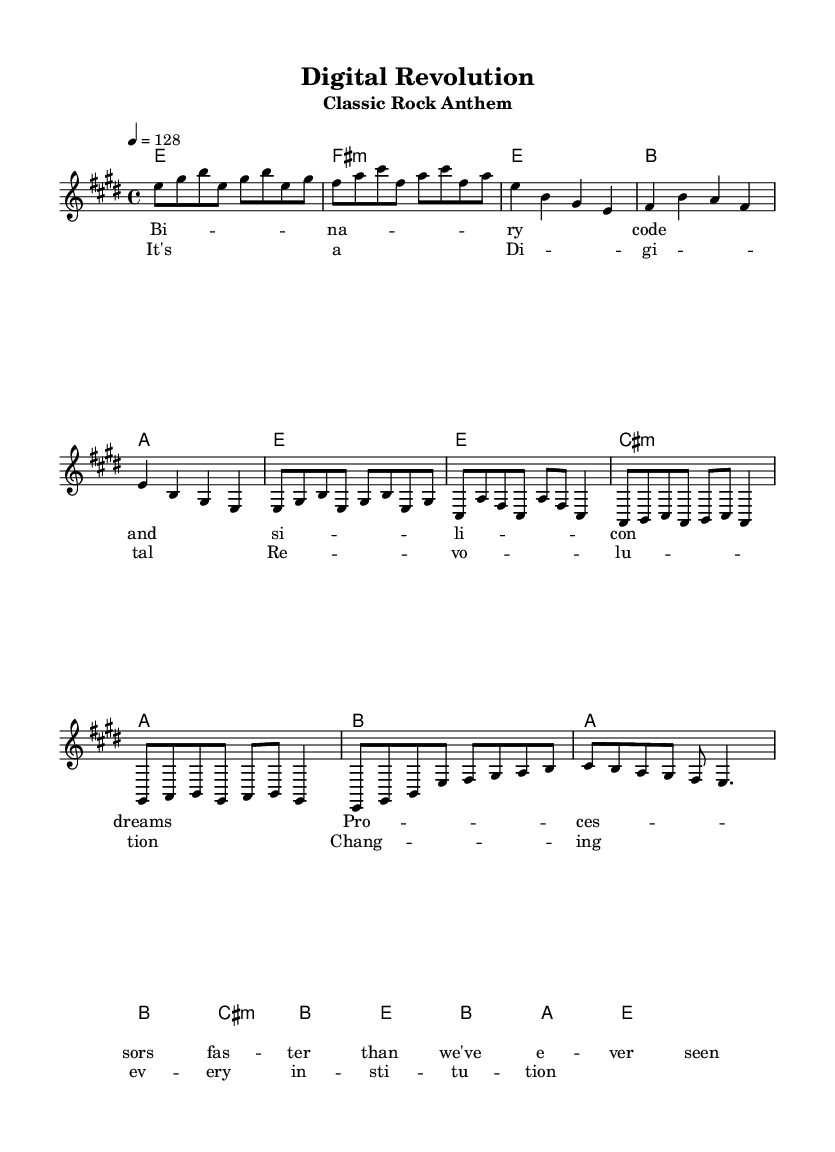What is the key signature of this music? The key signature indicated is E major, which has four sharps (F#, C#, G#, D#). This is confirmed by looking at the beginning of the staff where the sharps are placed.
Answer: E major What is the time signature of this music? The time signature displayed is 4/4, meaning there are four beats in each measure and the quarter note gets one beat, as shown at the beginning of the score.
Answer: 4/4 What is the tempo marking for the piece? The tempo marking is given as "4 = 128," which indicates that there should be 128 beats per minute, as seen in the tempo section at the beginning of the sheet music.
Answer: 128 How many measures are in the chorus section? The chorus consists of four measures, which can be counted in the melody line under the chorus lyrics section that aligns with the notes.
Answer: 4 What is the primary literary theme explored in the verse lyrics? The verse lyrics refer to "Binary code and silicon dreams," which suggests themes of technology and innovation, as derived from key phrases in the lyric section of the score.
Answer: Technology What musical structure is used in the solo section? The musical structure follows an abbreviated solo format, consisting of specific notes that represent a concise melody; it serves as a break from the typical verse-chorus routine. This is deduced from the section labeling in the melody.
Answer: Abbreviated solo Which notes are predominantly used in the introduction? The introduction prominently features the notes e, gis, and b, which can be observed in the melody line where the introductory phrases are notated.
Answer: e, gis, b 